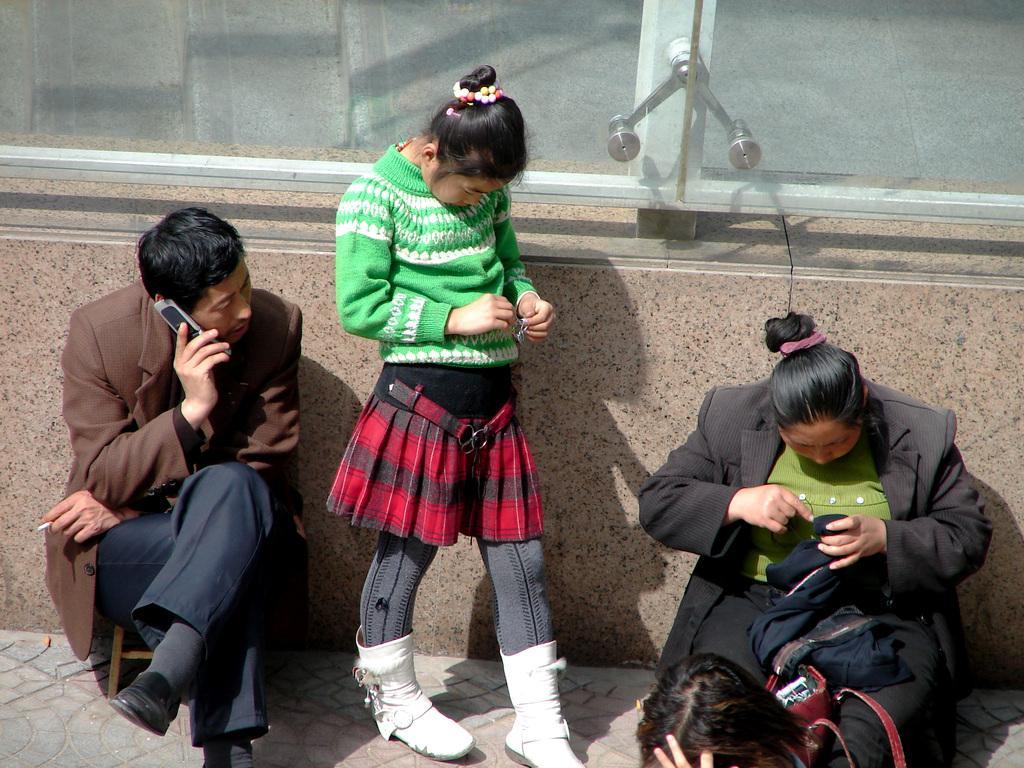How would you summarize this image in a sentence or two? This image consists of 3 persons in the middle. The man is on the left side. He is speaking on the phone. The woman is on the right side, she is doing something. 